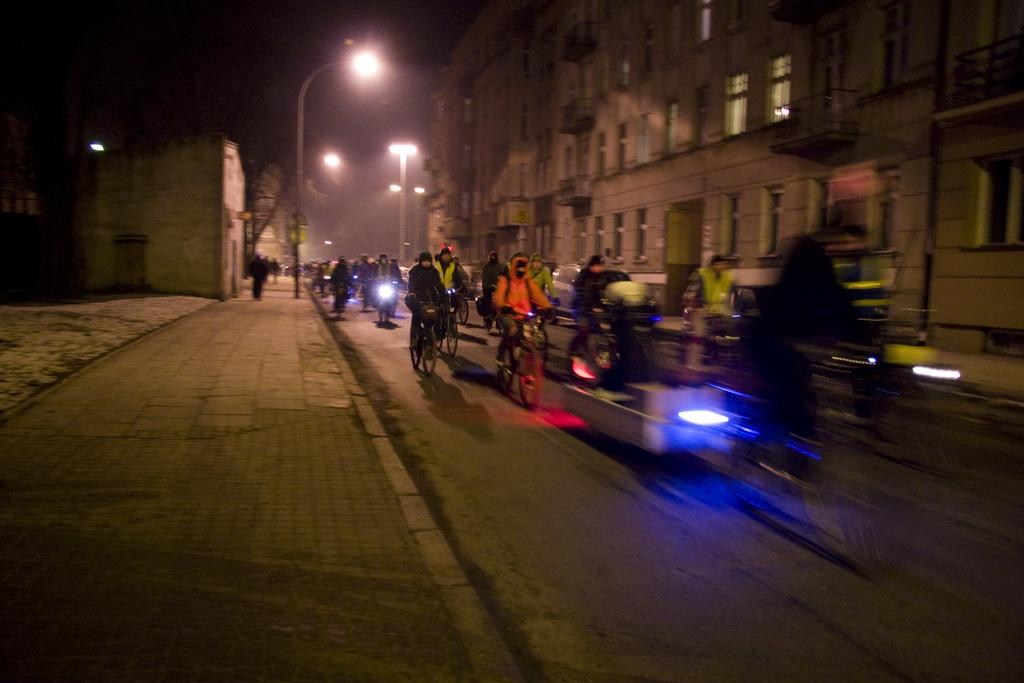What are the people in the image doing? The people in the image are riding vehicles on the road. What structures can be seen along the road? There are light poles visible in the image. What else can be seen in the image besides the people and vehicles? There are buildings in the image. How would you describe the lighting conditions in the image? The background of the image is dark. Can you describe the scene in the background? There are people and a tree visible in the background. What type of ship can be seen sailing in the background of the image? There is no ship visible in the image; it features people riding vehicles on the road with a dark background. How many tomatoes are being stitched together by the people in the image? There are no tomatoes or stitching activities present in the image. 